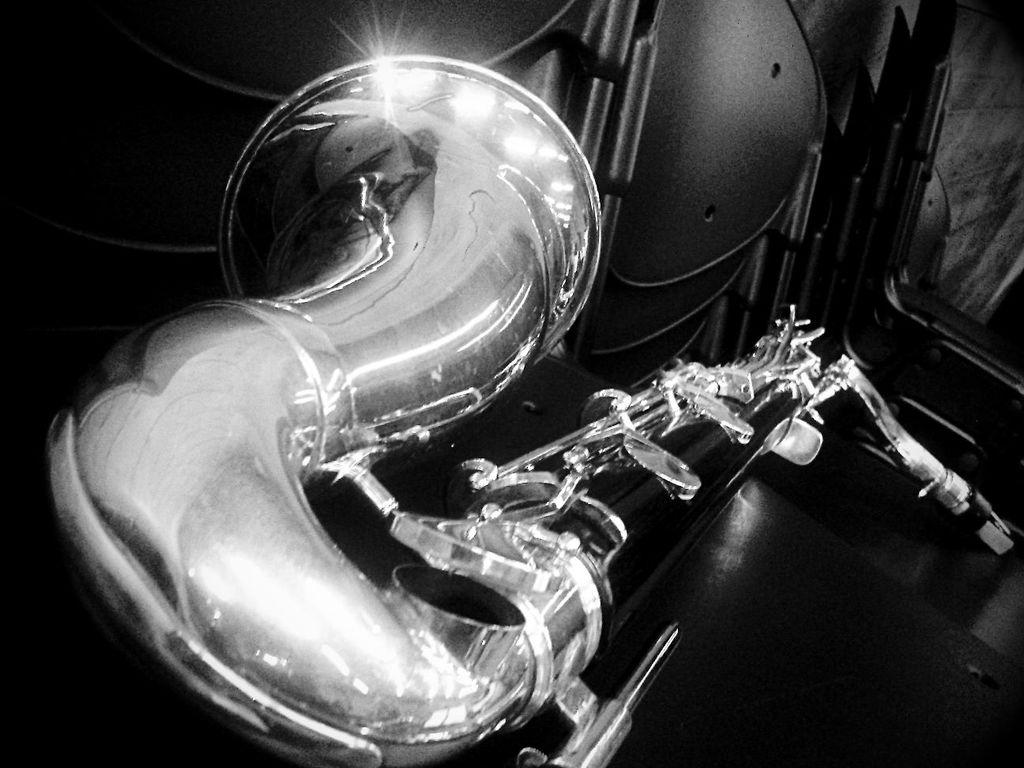What is the color scheme of the image? The image is black and white. What musical instrument can be seen in the image? There is a saxophone in the image. Where is the saxophone located in the image? The saxophone is placed on a table. What type of art is being performed on the saxophone in the image? There is no indication of any art being performed on the saxophone in the image, as it is simply placed on a table. Can you hear the song being played by the saxophone in the image? The image is static and does not contain any sound, so it is not possible to hear a song being played by the saxophone. 